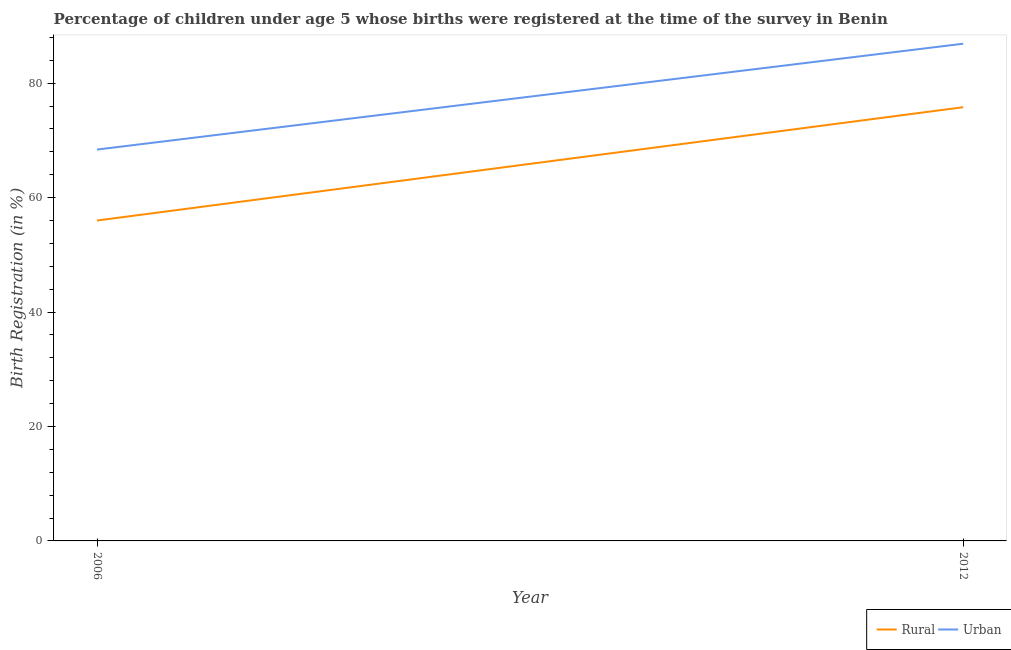How many different coloured lines are there?
Your answer should be very brief. 2. What is the rural birth registration in 2012?
Offer a very short reply. 75.8. Across all years, what is the maximum urban birth registration?
Give a very brief answer. 86.9. Across all years, what is the minimum urban birth registration?
Keep it short and to the point. 68.4. In which year was the rural birth registration minimum?
Your answer should be very brief. 2006. What is the total rural birth registration in the graph?
Provide a succinct answer. 131.8. What is the difference between the rural birth registration in 2006 and that in 2012?
Make the answer very short. -19.8. What is the difference between the urban birth registration in 2012 and the rural birth registration in 2006?
Offer a terse response. 30.9. What is the average urban birth registration per year?
Offer a terse response. 77.65. In the year 2012, what is the difference between the urban birth registration and rural birth registration?
Keep it short and to the point. 11.1. In how many years, is the rural birth registration greater than 72 %?
Provide a succinct answer. 1. What is the ratio of the rural birth registration in 2006 to that in 2012?
Ensure brevity in your answer.  0.74. In how many years, is the urban birth registration greater than the average urban birth registration taken over all years?
Your response must be concise. 1. Does the rural birth registration monotonically increase over the years?
Provide a succinct answer. Yes. Is the urban birth registration strictly less than the rural birth registration over the years?
Offer a very short reply. No. How many lines are there?
Ensure brevity in your answer.  2. What is the difference between two consecutive major ticks on the Y-axis?
Your answer should be compact. 20. Are the values on the major ticks of Y-axis written in scientific E-notation?
Keep it short and to the point. No. Does the graph contain any zero values?
Give a very brief answer. No. Where does the legend appear in the graph?
Your answer should be very brief. Bottom right. How many legend labels are there?
Provide a succinct answer. 2. How are the legend labels stacked?
Provide a succinct answer. Horizontal. What is the title of the graph?
Your answer should be compact. Percentage of children under age 5 whose births were registered at the time of the survey in Benin. What is the label or title of the Y-axis?
Make the answer very short. Birth Registration (in %). What is the Birth Registration (in %) in Urban in 2006?
Your response must be concise. 68.4. What is the Birth Registration (in %) in Rural in 2012?
Provide a succinct answer. 75.8. What is the Birth Registration (in %) in Urban in 2012?
Your answer should be compact. 86.9. Across all years, what is the maximum Birth Registration (in %) in Rural?
Keep it short and to the point. 75.8. Across all years, what is the maximum Birth Registration (in %) of Urban?
Your response must be concise. 86.9. Across all years, what is the minimum Birth Registration (in %) of Rural?
Provide a succinct answer. 56. Across all years, what is the minimum Birth Registration (in %) of Urban?
Your response must be concise. 68.4. What is the total Birth Registration (in %) of Rural in the graph?
Provide a short and direct response. 131.8. What is the total Birth Registration (in %) in Urban in the graph?
Give a very brief answer. 155.3. What is the difference between the Birth Registration (in %) in Rural in 2006 and that in 2012?
Offer a very short reply. -19.8. What is the difference between the Birth Registration (in %) of Urban in 2006 and that in 2012?
Offer a very short reply. -18.5. What is the difference between the Birth Registration (in %) of Rural in 2006 and the Birth Registration (in %) of Urban in 2012?
Your answer should be compact. -30.9. What is the average Birth Registration (in %) in Rural per year?
Your response must be concise. 65.9. What is the average Birth Registration (in %) of Urban per year?
Your response must be concise. 77.65. In the year 2006, what is the difference between the Birth Registration (in %) in Rural and Birth Registration (in %) in Urban?
Your answer should be compact. -12.4. What is the ratio of the Birth Registration (in %) of Rural in 2006 to that in 2012?
Offer a very short reply. 0.74. What is the ratio of the Birth Registration (in %) of Urban in 2006 to that in 2012?
Ensure brevity in your answer.  0.79. What is the difference between the highest and the second highest Birth Registration (in %) in Rural?
Provide a short and direct response. 19.8. What is the difference between the highest and the lowest Birth Registration (in %) of Rural?
Give a very brief answer. 19.8. What is the difference between the highest and the lowest Birth Registration (in %) in Urban?
Offer a terse response. 18.5. 